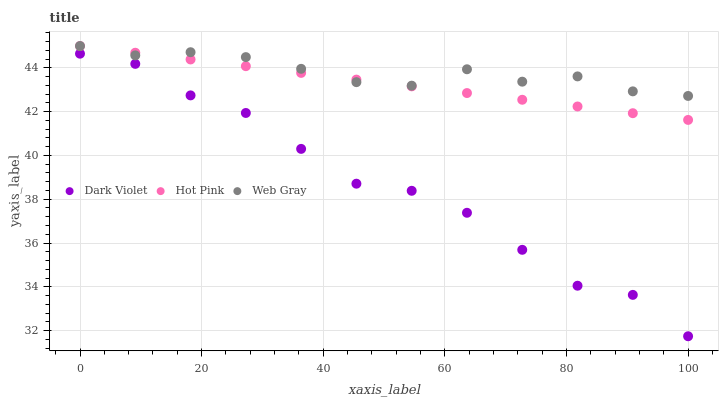Does Dark Violet have the minimum area under the curve?
Answer yes or no. Yes. Does Web Gray have the maximum area under the curve?
Answer yes or no. Yes. Does Web Gray have the minimum area under the curve?
Answer yes or no. No. Does Dark Violet have the maximum area under the curve?
Answer yes or no. No. Is Hot Pink the smoothest?
Answer yes or no. Yes. Is Dark Violet the roughest?
Answer yes or no. Yes. Is Web Gray the smoothest?
Answer yes or no. No. Is Web Gray the roughest?
Answer yes or no. No. Does Dark Violet have the lowest value?
Answer yes or no. Yes. Does Web Gray have the lowest value?
Answer yes or no. No. Does Web Gray have the highest value?
Answer yes or no. Yes. Does Dark Violet have the highest value?
Answer yes or no. No. Is Dark Violet less than Hot Pink?
Answer yes or no. Yes. Is Hot Pink greater than Dark Violet?
Answer yes or no. Yes. Does Hot Pink intersect Web Gray?
Answer yes or no. Yes. Is Hot Pink less than Web Gray?
Answer yes or no. No. Is Hot Pink greater than Web Gray?
Answer yes or no. No. Does Dark Violet intersect Hot Pink?
Answer yes or no. No. 